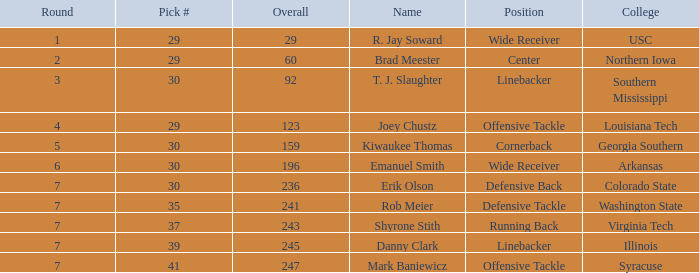What is the Position with a round 3 pick for r. jay soward? Wide Receiver. 